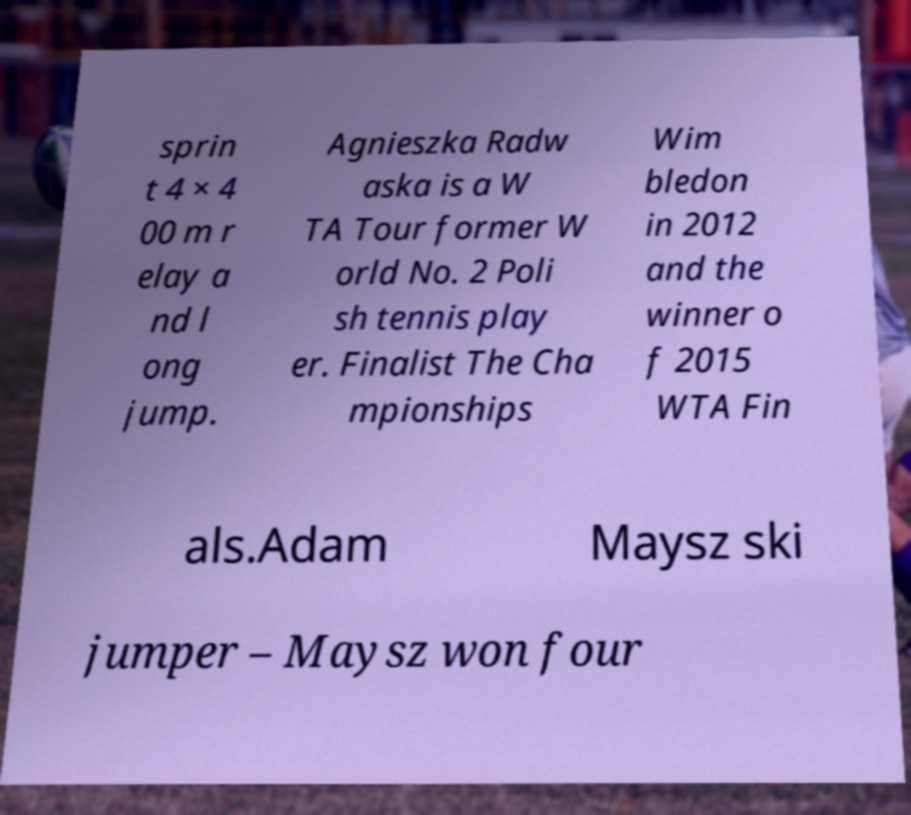For documentation purposes, I need the text within this image transcribed. Could you provide that? sprin t 4 × 4 00 m r elay a nd l ong jump. Agnieszka Radw aska is a W TA Tour former W orld No. 2 Poli sh tennis play er. Finalist The Cha mpionships Wim bledon in 2012 and the winner o f 2015 WTA Fin als.Adam Maysz ski jumper – Maysz won four 